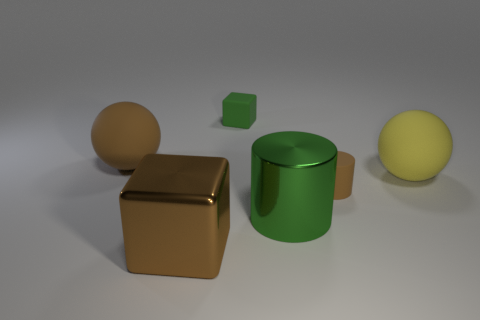Add 3 big green metal things. How many objects exist? 9 Subtract all cylinders. How many objects are left? 4 Subtract all big green cylinders. Subtract all large objects. How many objects are left? 1 Add 1 small rubber cubes. How many small rubber cubes are left? 2 Add 4 small green rubber things. How many small green rubber things exist? 5 Subtract 0 blue cylinders. How many objects are left? 6 